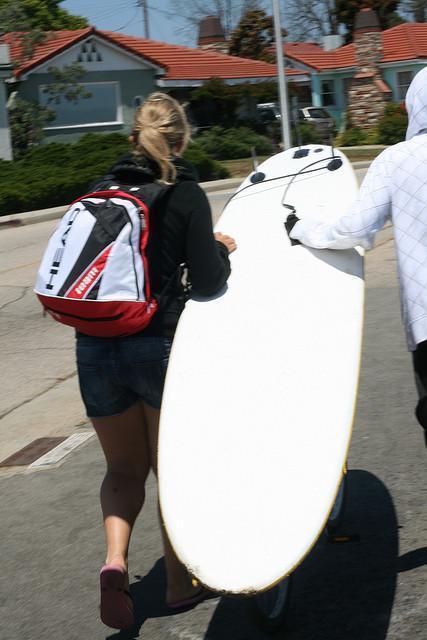How many people can be seen?
Give a very brief answer. 2. How many red suitcases are in this picture?
Give a very brief answer. 0. 